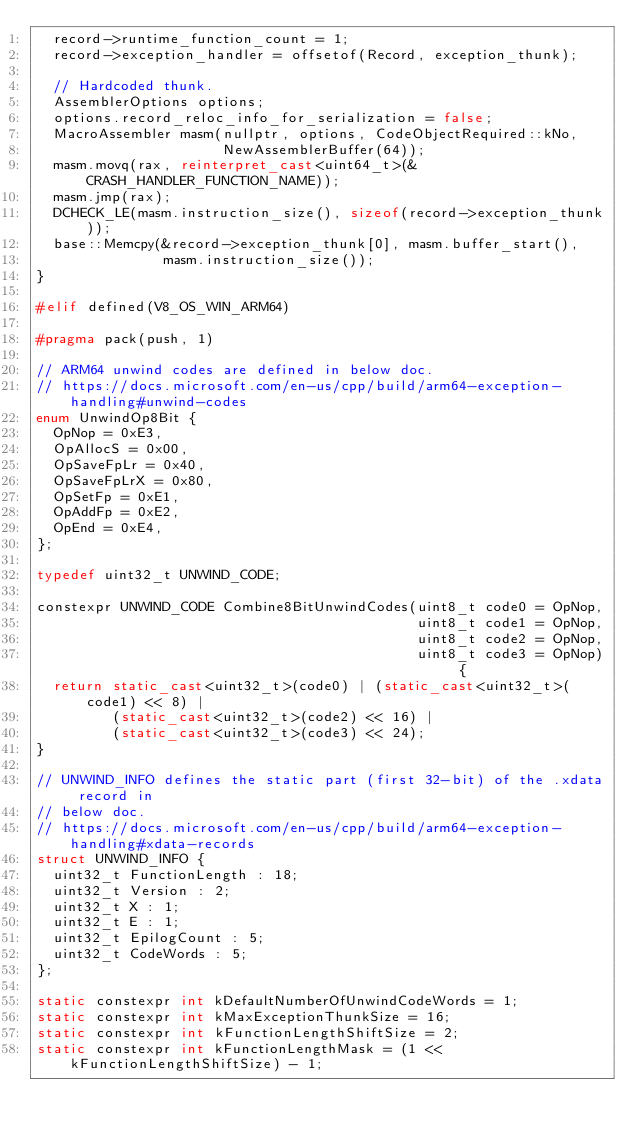Convert code to text. <code><loc_0><loc_0><loc_500><loc_500><_C++_>  record->runtime_function_count = 1;
  record->exception_handler = offsetof(Record, exception_thunk);

  // Hardcoded thunk.
  AssemblerOptions options;
  options.record_reloc_info_for_serialization = false;
  MacroAssembler masm(nullptr, options, CodeObjectRequired::kNo,
                      NewAssemblerBuffer(64));
  masm.movq(rax, reinterpret_cast<uint64_t>(&CRASH_HANDLER_FUNCTION_NAME));
  masm.jmp(rax);
  DCHECK_LE(masm.instruction_size(), sizeof(record->exception_thunk));
  base::Memcpy(&record->exception_thunk[0], masm.buffer_start(),
               masm.instruction_size());
}

#elif defined(V8_OS_WIN_ARM64)

#pragma pack(push, 1)

// ARM64 unwind codes are defined in below doc.
// https://docs.microsoft.com/en-us/cpp/build/arm64-exception-handling#unwind-codes
enum UnwindOp8Bit {
  OpNop = 0xE3,
  OpAllocS = 0x00,
  OpSaveFpLr = 0x40,
  OpSaveFpLrX = 0x80,
  OpSetFp = 0xE1,
  OpAddFp = 0xE2,
  OpEnd = 0xE4,
};

typedef uint32_t UNWIND_CODE;

constexpr UNWIND_CODE Combine8BitUnwindCodes(uint8_t code0 = OpNop,
                                             uint8_t code1 = OpNop,
                                             uint8_t code2 = OpNop,
                                             uint8_t code3 = OpNop) {
  return static_cast<uint32_t>(code0) | (static_cast<uint32_t>(code1) << 8) |
         (static_cast<uint32_t>(code2) << 16) |
         (static_cast<uint32_t>(code3) << 24);
}

// UNWIND_INFO defines the static part (first 32-bit) of the .xdata record in
// below doc.
// https://docs.microsoft.com/en-us/cpp/build/arm64-exception-handling#xdata-records
struct UNWIND_INFO {
  uint32_t FunctionLength : 18;
  uint32_t Version : 2;
  uint32_t X : 1;
  uint32_t E : 1;
  uint32_t EpilogCount : 5;
  uint32_t CodeWords : 5;
};

static constexpr int kDefaultNumberOfUnwindCodeWords = 1;
static constexpr int kMaxExceptionThunkSize = 16;
static constexpr int kFunctionLengthShiftSize = 2;
static constexpr int kFunctionLengthMask = (1 << kFunctionLengthShiftSize) - 1;</code> 